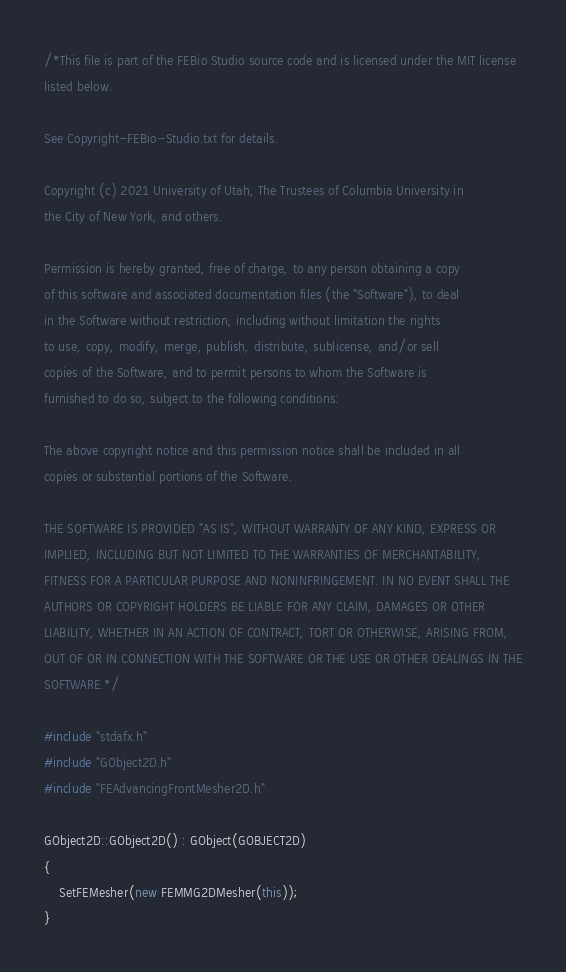Convert code to text. <code><loc_0><loc_0><loc_500><loc_500><_C++_>/*This file is part of the FEBio Studio source code and is licensed under the MIT license
listed below.

See Copyright-FEBio-Studio.txt for details.

Copyright (c) 2021 University of Utah, The Trustees of Columbia University in
the City of New York, and others.

Permission is hereby granted, free of charge, to any person obtaining a copy
of this software and associated documentation files (the "Software"), to deal
in the Software without restriction, including without limitation the rights
to use, copy, modify, merge, publish, distribute, sublicense, and/or sell
copies of the Software, and to permit persons to whom the Software is
furnished to do so, subject to the following conditions:

The above copyright notice and this permission notice shall be included in all
copies or substantial portions of the Software.

THE SOFTWARE IS PROVIDED "AS IS", WITHOUT WARRANTY OF ANY KIND, EXPRESS OR
IMPLIED, INCLUDING BUT NOT LIMITED TO THE WARRANTIES OF MERCHANTABILITY,
FITNESS FOR A PARTICULAR PURPOSE AND NONINFRINGEMENT. IN NO EVENT SHALL THE
AUTHORS OR COPYRIGHT HOLDERS BE LIABLE FOR ANY CLAIM, DAMAGES OR OTHER
LIABILITY, WHETHER IN AN ACTION OF CONTRACT, TORT OR OTHERWISE, ARISING FROM,
OUT OF OR IN CONNECTION WITH THE SOFTWARE OR THE USE OR OTHER DEALINGS IN THE
SOFTWARE.*/

#include "stdafx.h"
#include "GObject2D.h"
#include "FEAdvancingFrontMesher2D.h"

GObject2D::GObject2D() : GObject(GOBJECT2D)
{
	SetFEMesher(new FEMMG2DMesher(this));
}
</code> 